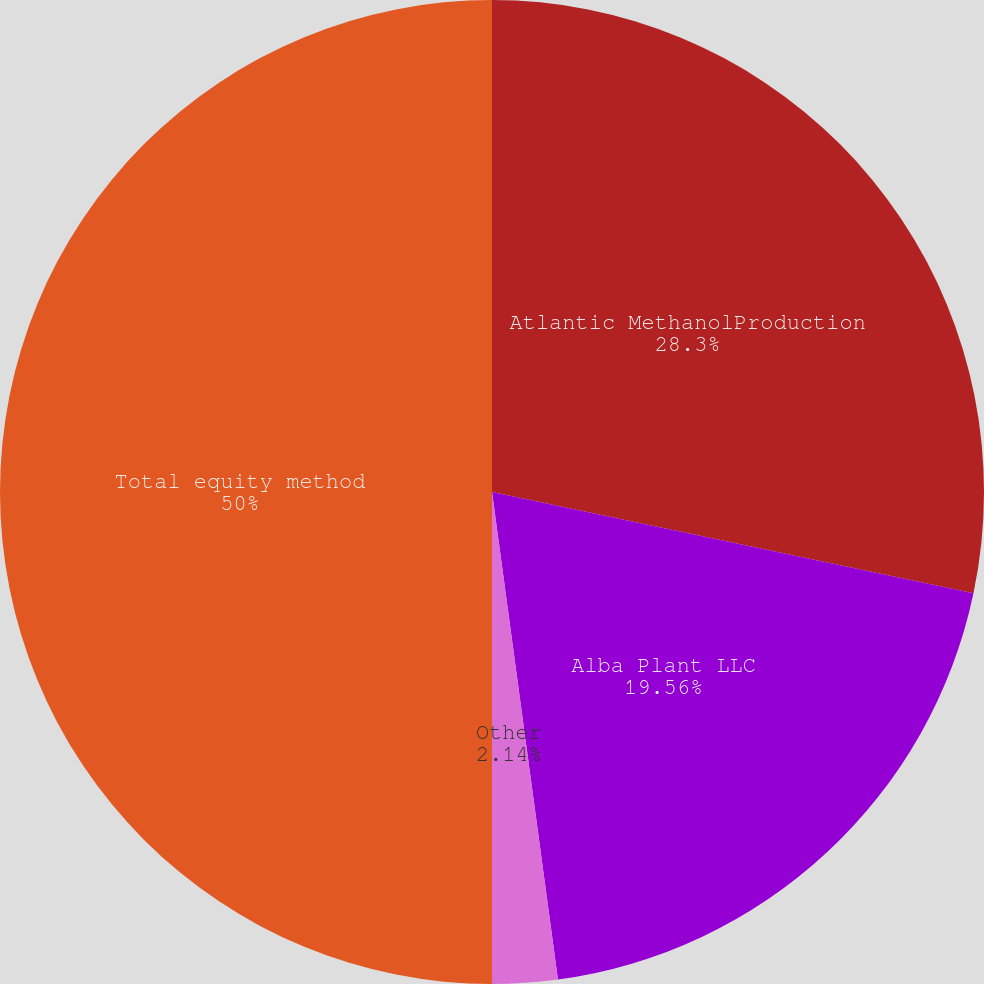Convert chart. <chart><loc_0><loc_0><loc_500><loc_500><pie_chart><fcel>Atlantic MethanolProduction<fcel>Alba Plant LLC<fcel>Other<fcel>Total equity method<nl><fcel>28.3%<fcel>19.56%<fcel>2.14%<fcel>50.0%<nl></chart> 